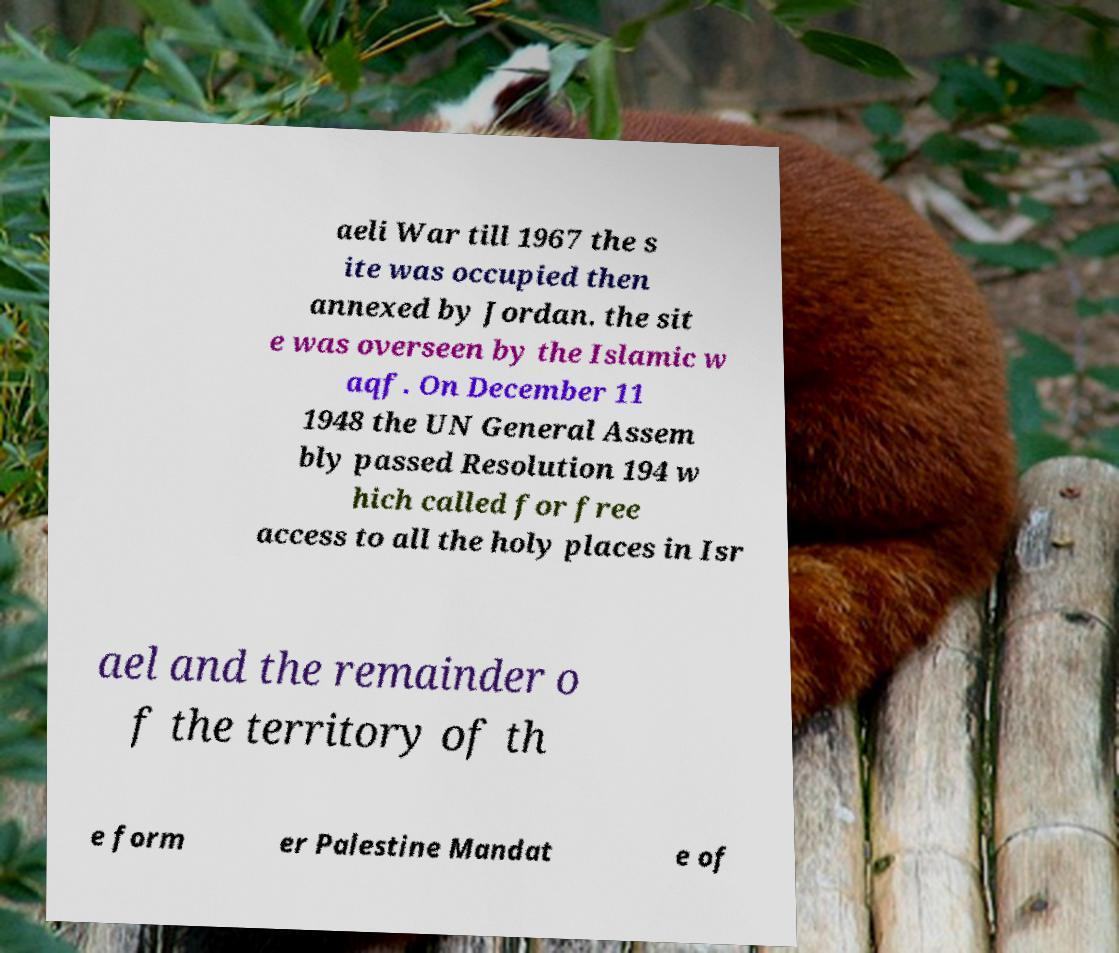Please read and relay the text visible in this image. What does it say? aeli War till 1967 the s ite was occupied then annexed by Jordan. the sit e was overseen by the Islamic w aqf. On December 11 1948 the UN General Assem bly passed Resolution 194 w hich called for free access to all the holy places in Isr ael and the remainder o f the territory of th e form er Palestine Mandat e of 